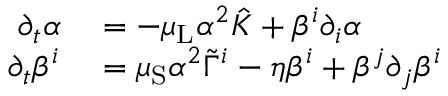Convert formula to latex. <formula><loc_0><loc_0><loc_500><loc_500>\begin{array} { r l } { \partial _ { t } \alpha } & = - \mu _ { L } \alpha ^ { 2 } \hat { K } + \beta ^ { i } \partial _ { i } \alpha } \\ { \partial _ { t } \beta ^ { i } } & = \mu _ { S } \alpha ^ { 2 } \tilde { \Gamma } ^ { i } - \eta \beta ^ { i } + \beta ^ { j } \partial _ { j } \beta ^ { i } } \end{array}</formula> 